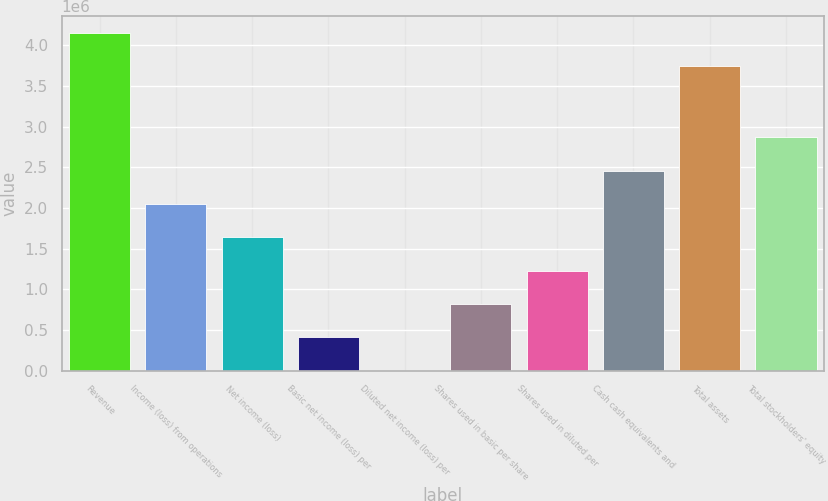<chart> <loc_0><loc_0><loc_500><loc_500><bar_chart><fcel>Revenue<fcel>Income (loss) from operations<fcel>Net income (loss)<fcel>Basic net income (loss) per<fcel>Diluted net income (loss) per<fcel>Shares used in basic per share<fcel>Shares used in diluted per<fcel>Cash cash equivalents and<fcel>Total assets<fcel>Total stockholders' equity<nl><fcel>4.15746e+06<fcel>2.04893e+06<fcel>1.63914e+06<fcel>409787<fcel>1.31<fcel>819573<fcel>1.22936e+06<fcel>2.45872e+06<fcel>3.74767e+06<fcel>2.8685e+06<nl></chart> 